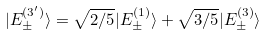Convert formula to latex. <formula><loc_0><loc_0><loc_500><loc_500>| E ^ { ( 3 ^ { \prime } ) } _ { \pm } \rangle = \sqrt { 2 / 5 } | E _ { \pm } ^ { ( 1 ) } \rangle + \sqrt { 3 / 5 } | E _ { \pm } ^ { ( 3 ) } \rangle</formula> 